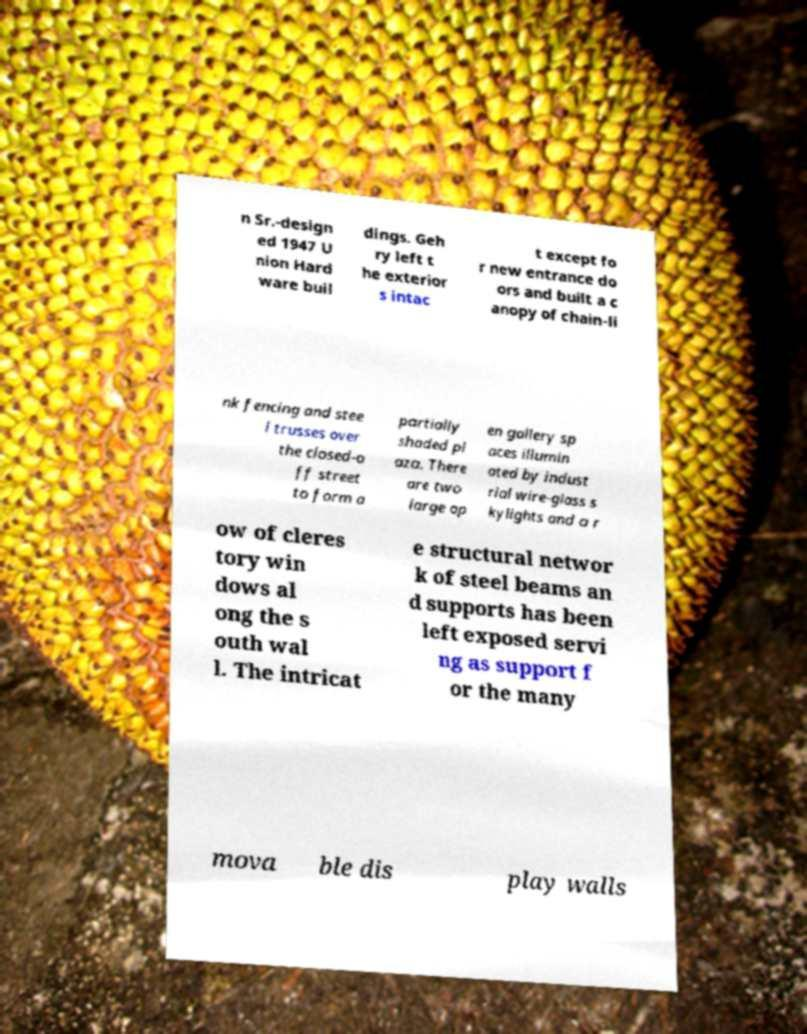What messages or text are displayed in this image? I need them in a readable, typed format. n Sr.-design ed 1947 U nion Hard ware buil dings. Geh ry left t he exterior s intac t except fo r new entrance do ors and built a c anopy of chain-li nk fencing and stee l trusses over the closed-o ff street to form a partially shaded pl aza. There are two large op en gallery sp aces illumin ated by indust rial wire-glass s kylights and a r ow of cleres tory win dows al ong the s outh wal l. The intricat e structural networ k of steel beams an d supports has been left exposed servi ng as support f or the many mova ble dis play walls 